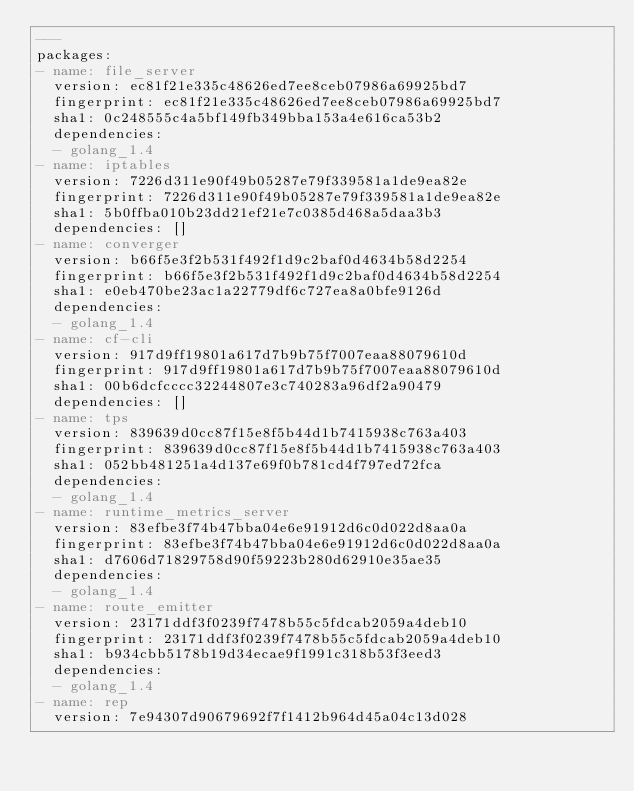Convert code to text. <code><loc_0><loc_0><loc_500><loc_500><_YAML_>---
packages:
- name: file_server
  version: ec81f21e335c48626ed7ee8ceb07986a69925bd7
  fingerprint: ec81f21e335c48626ed7ee8ceb07986a69925bd7
  sha1: 0c248555c4a5bf149fb349bba153a4e616ca53b2
  dependencies:
  - golang_1.4
- name: iptables
  version: 7226d311e90f49b05287e79f339581a1de9ea82e
  fingerprint: 7226d311e90f49b05287e79f339581a1de9ea82e
  sha1: 5b0ffba010b23dd21ef21e7c0385d468a5daa3b3
  dependencies: []
- name: converger
  version: b66f5e3f2b531f492f1d9c2baf0d4634b58d2254
  fingerprint: b66f5e3f2b531f492f1d9c2baf0d4634b58d2254
  sha1: e0eb470be23ac1a22779df6c727ea8a0bfe9126d
  dependencies:
  - golang_1.4
- name: cf-cli
  version: 917d9ff19801a617d7b9b75f7007eaa88079610d
  fingerprint: 917d9ff19801a617d7b9b75f7007eaa88079610d
  sha1: 00b6dcfcccc32244807e3c740283a96df2a90479
  dependencies: []
- name: tps
  version: 839639d0cc87f15e8f5b44d1b7415938c763a403
  fingerprint: 839639d0cc87f15e8f5b44d1b7415938c763a403
  sha1: 052bb481251a4d137e69f0b781cd4f797ed72fca
  dependencies:
  - golang_1.4
- name: runtime_metrics_server
  version: 83efbe3f74b47bba04e6e91912d6c0d022d8aa0a
  fingerprint: 83efbe3f74b47bba04e6e91912d6c0d022d8aa0a
  sha1: d7606d71829758d90f59223b280d62910e35ae35
  dependencies:
  - golang_1.4
- name: route_emitter
  version: 23171ddf3f0239f7478b55c5fdcab2059a4deb10
  fingerprint: 23171ddf3f0239f7478b55c5fdcab2059a4deb10
  sha1: b934cbb5178b19d34ecae9f1991c318b53f3eed3
  dependencies:
  - golang_1.4
- name: rep
  version: 7e94307d90679692f7f1412b964d45a04c13d028</code> 